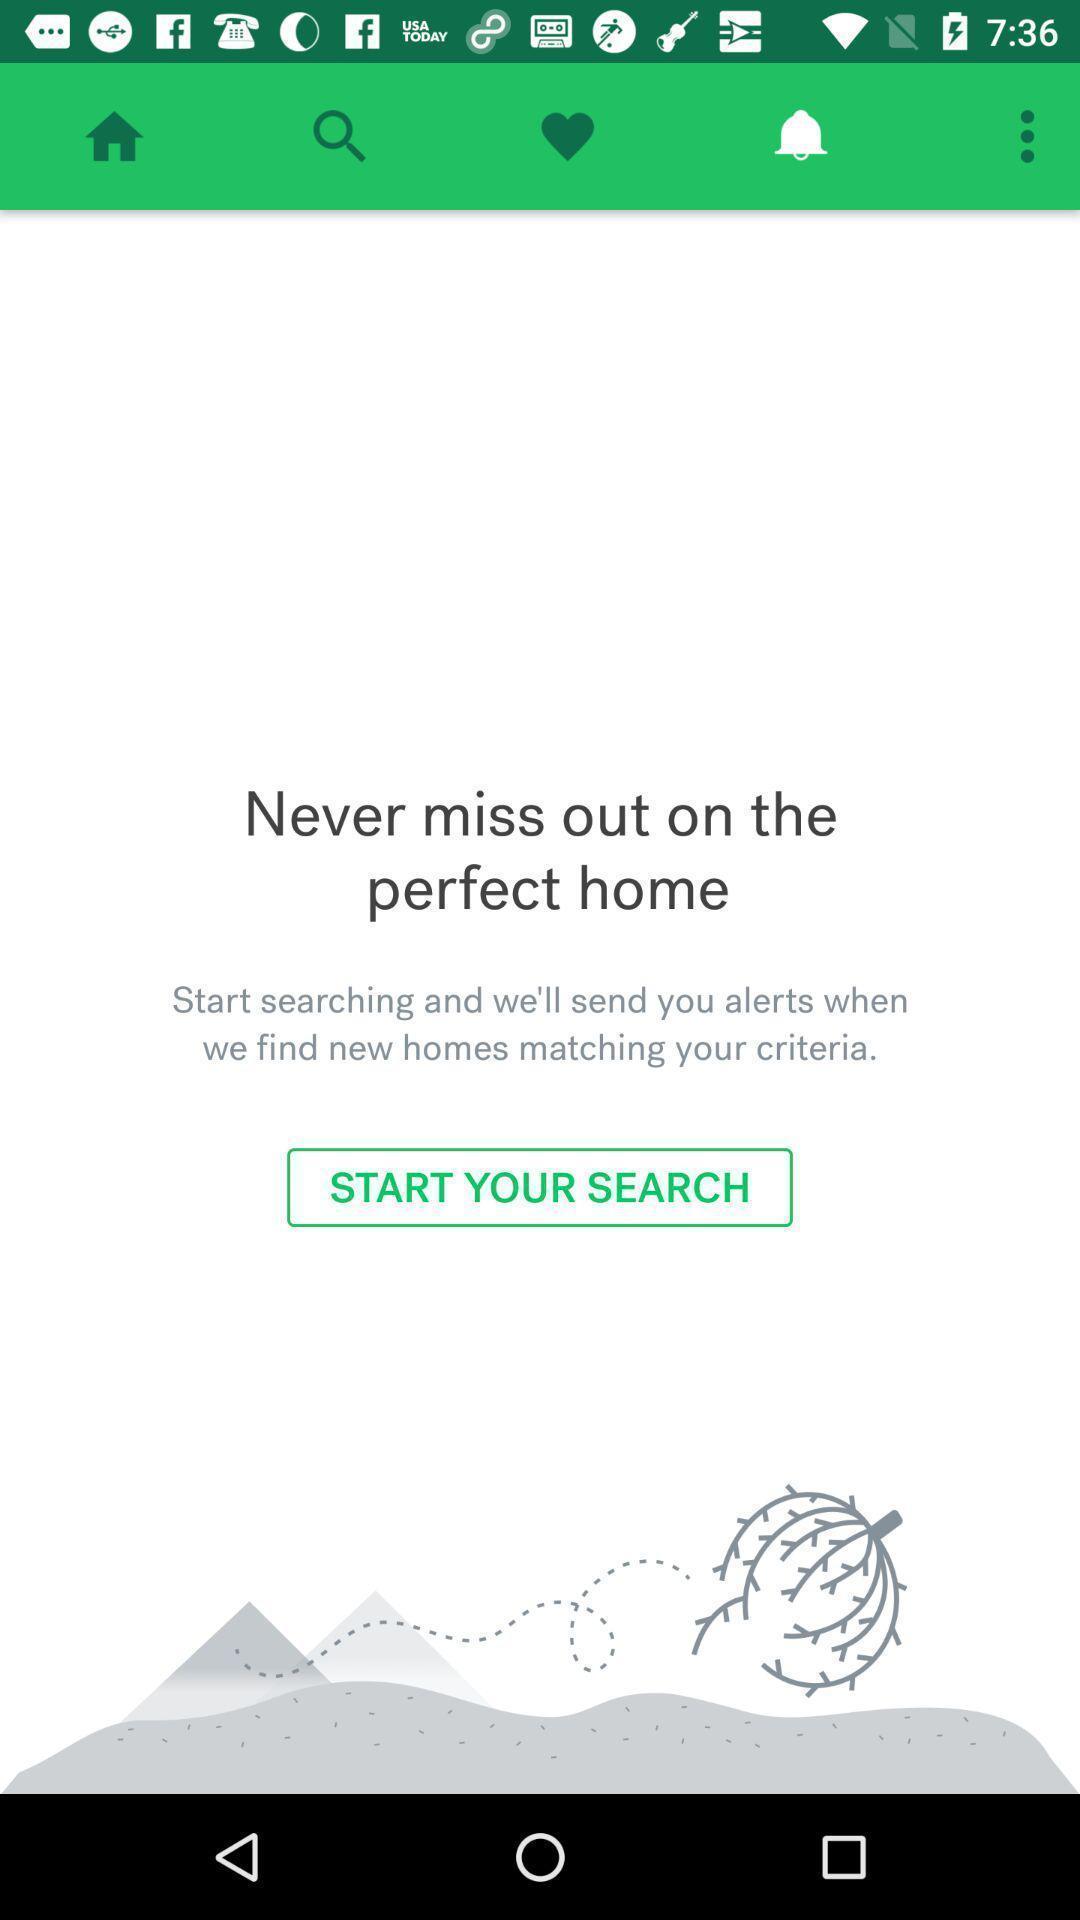What is the overall content of this screenshot? Page showing search option on app. 